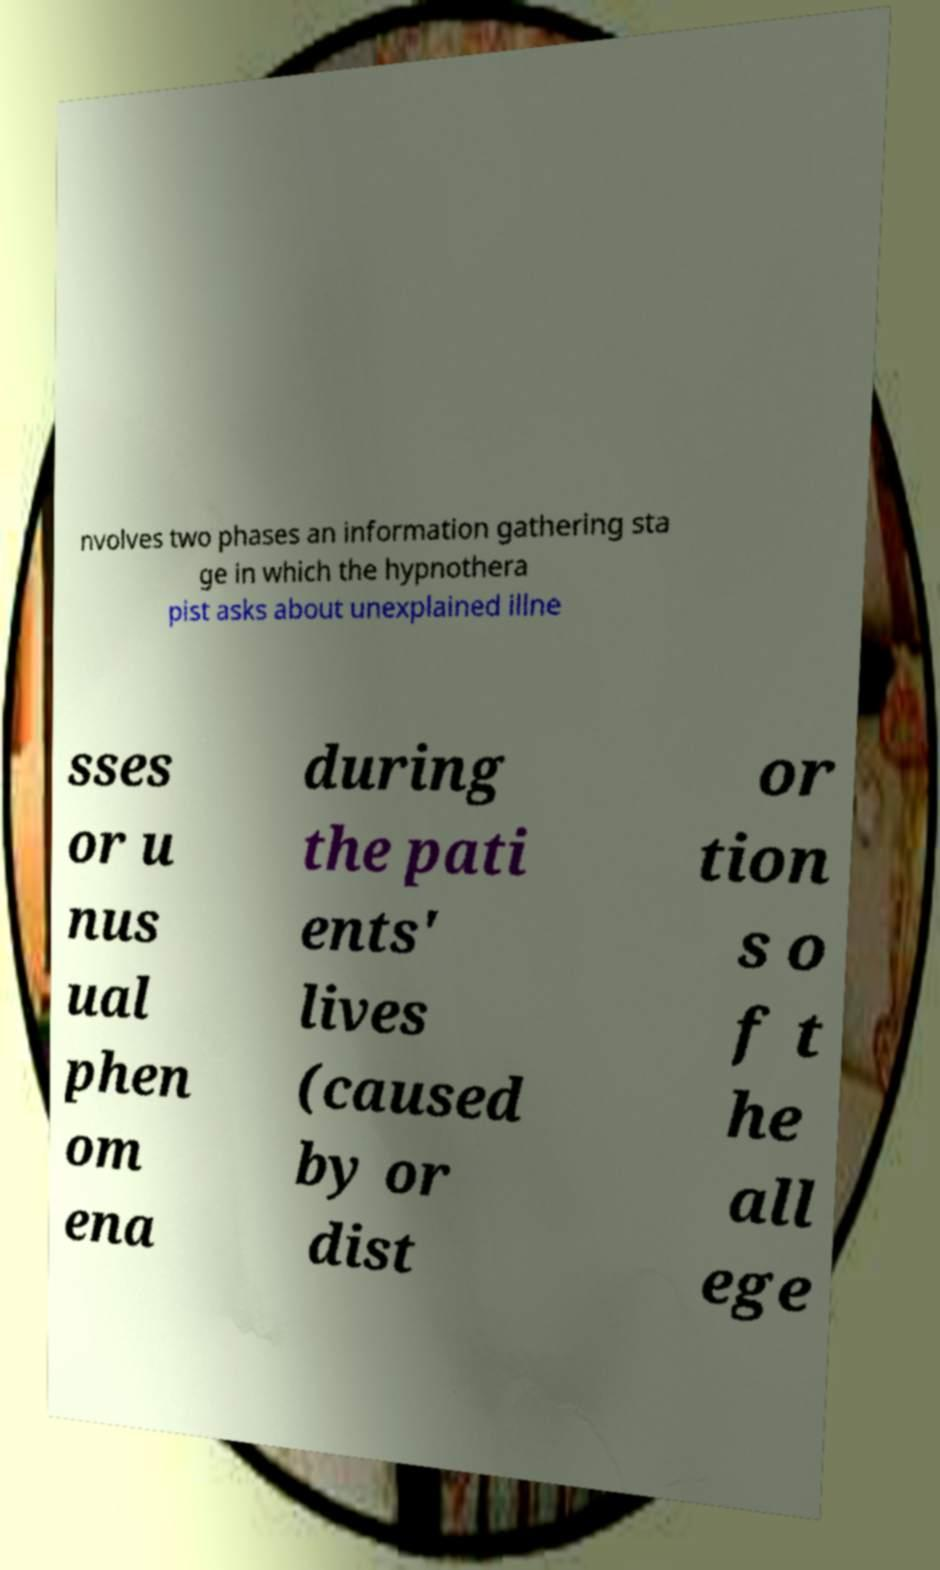There's text embedded in this image that I need extracted. Can you transcribe it verbatim? nvolves two phases an information gathering sta ge in which the hypnothera pist asks about unexplained illne sses or u nus ual phen om ena during the pati ents' lives (caused by or dist or tion s o f t he all ege 